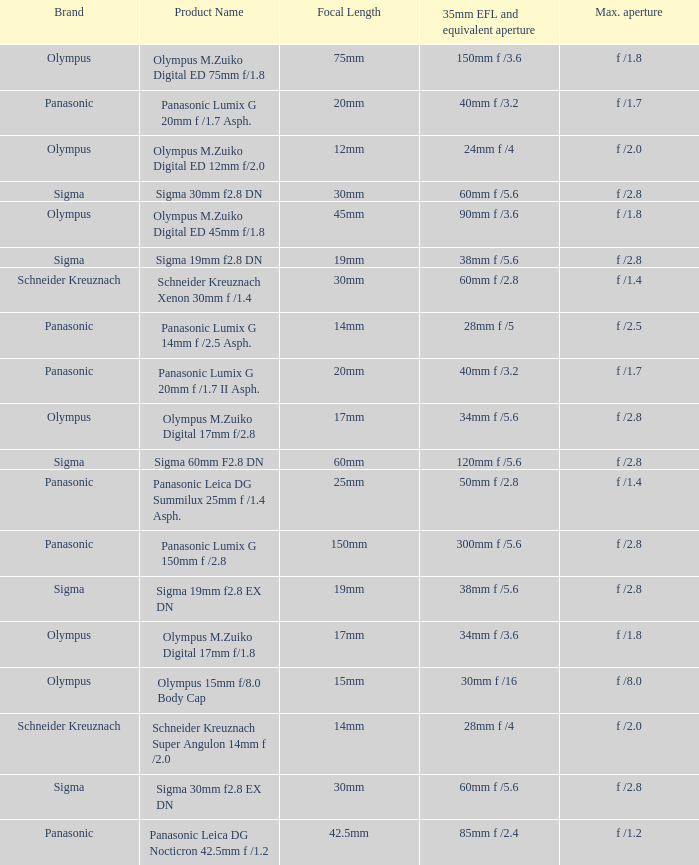What is the brand of the Sigma 30mm f2.8 DN, which has a maximum aperture of f /2.8 and a focal length of 30mm? Sigma. 